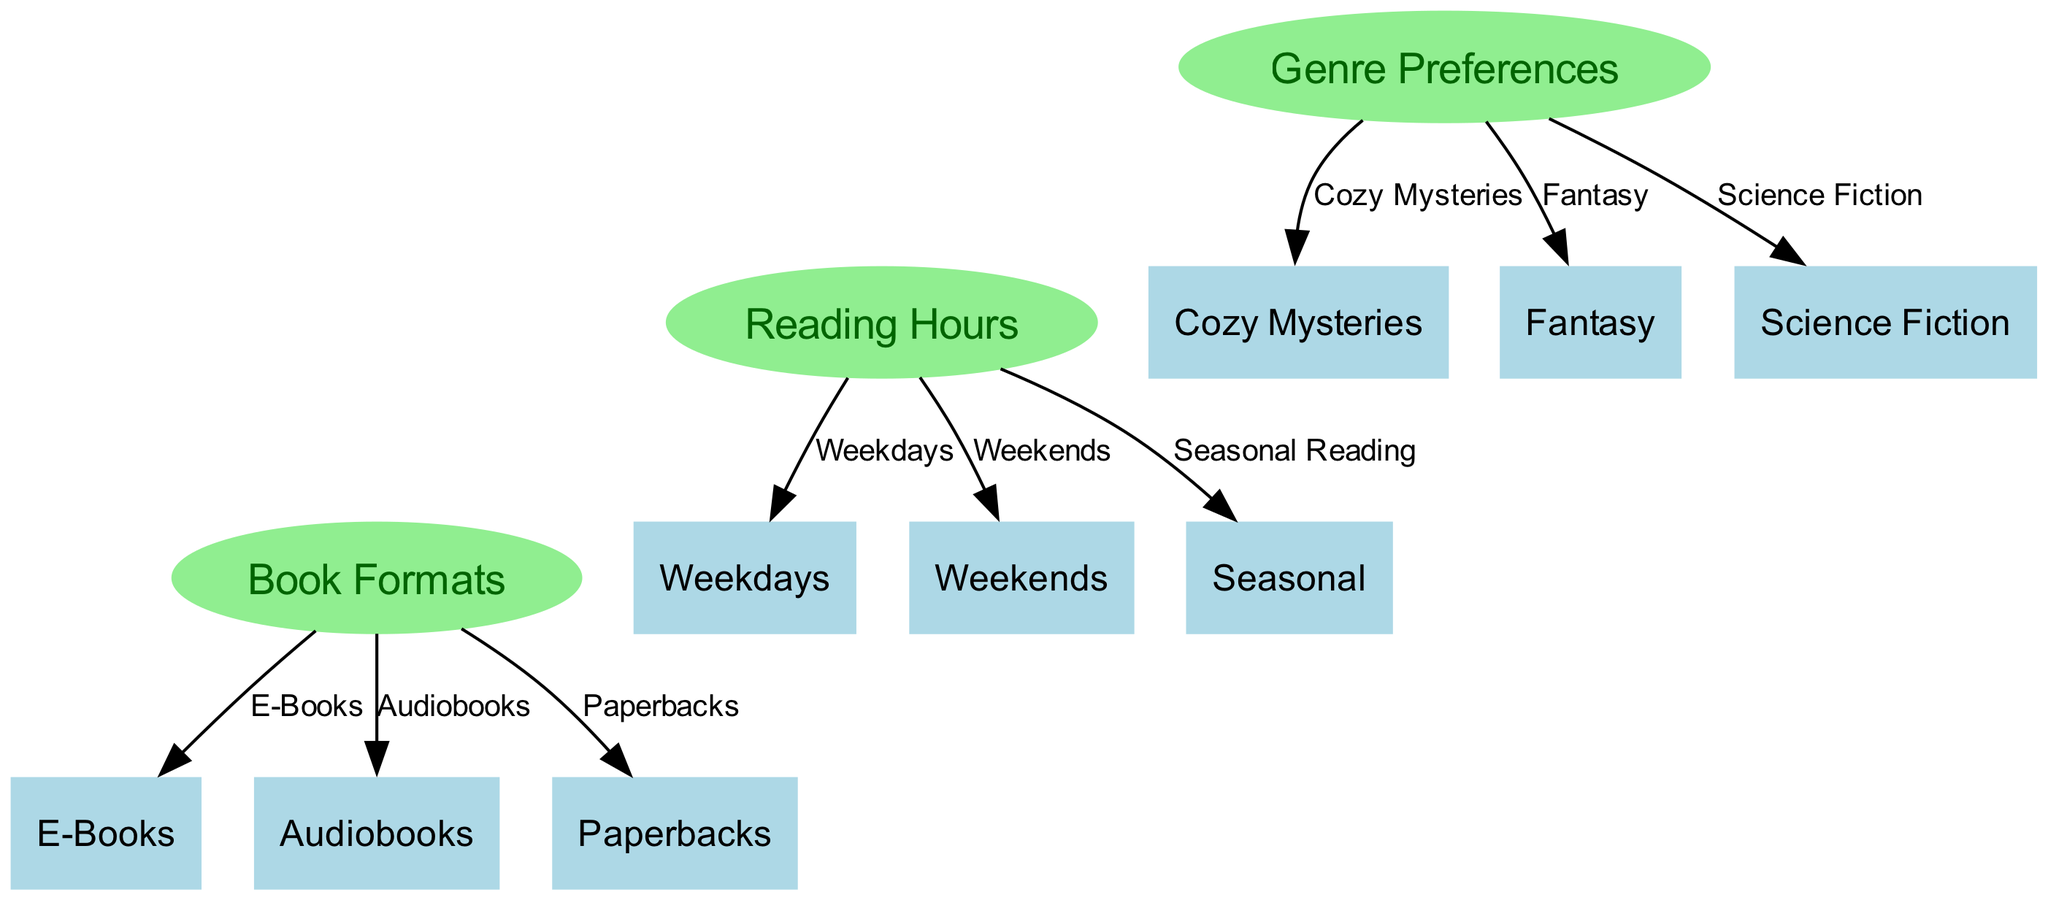What genres are included in genre preferences? The diagram shows the genre preferences node connected to three specific genres: cozy mysteries, fantasy, and science fiction. These associations indicate that these are the genres included in the category of genre preferences.
Answer: cozy mysteries, fantasy, science fiction How many edges are there connecting reading hours to its nodes? By examining the reading hours node, we can see it connects to three nodes: weekdays, weekends, and seasonal reading. Counting these connections gives us the total number of edges.
Answer: 3 What are the three book formats represented in the diagram? The book formats node links to three specific formats: e-books, audiobooks, and paperbacks. These provide the categories of book formats shown in the diagram.
Answer: E-Books, Audiobooks, Paperbacks Which reading period has the highest connectivity? The reading hours node connects to three other nodes: weekdays, weekends, and seasonal reading, suggesting it has the most connections. This indicates a variety of reading times for teenagers.
Answer: weekdays, weekends, seasonal Is there a relationship between genre preferences and reading hours? The diagram shows an invisible edge connecting genre preferences to reading hours. This implies that there is a conceptual relationship that connects what genres teenagers prefer to when they read.
Answer: Yes, there is a relationship 